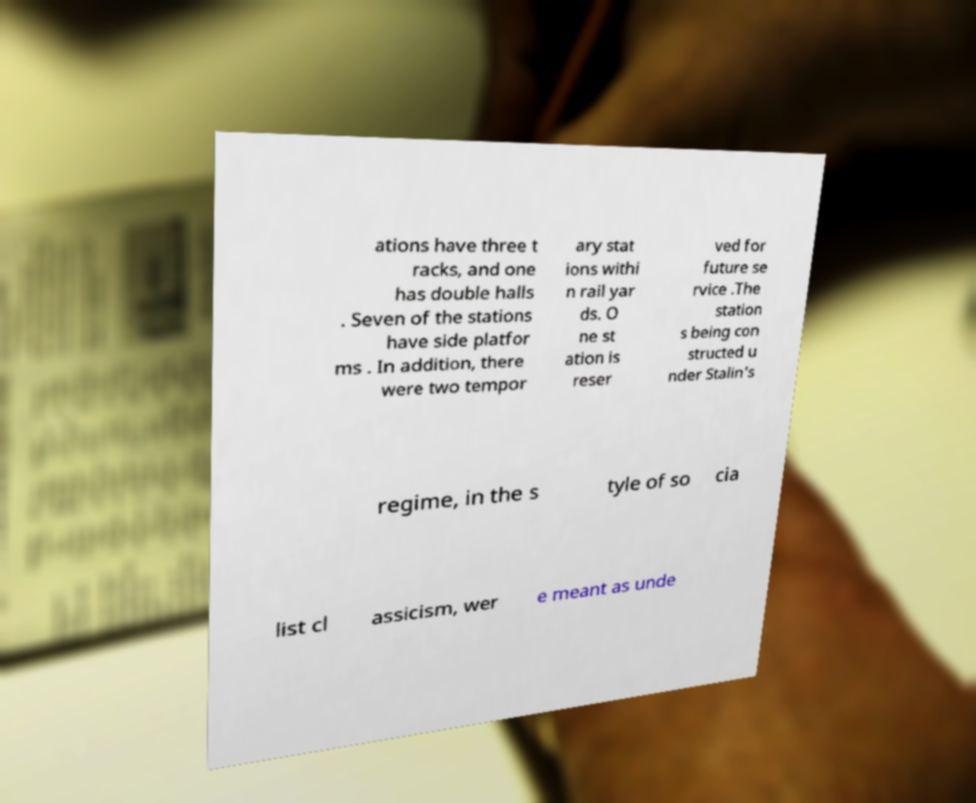Could you assist in decoding the text presented in this image and type it out clearly? ations have three t racks, and one has double halls . Seven of the stations have side platfor ms . In addition, there were two tempor ary stat ions withi n rail yar ds. O ne st ation is reser ved for future se rvice .The station s being con structed u nder Stalin's regime, in the s tyle of so cia list cl assicism, wer e meant as unde 